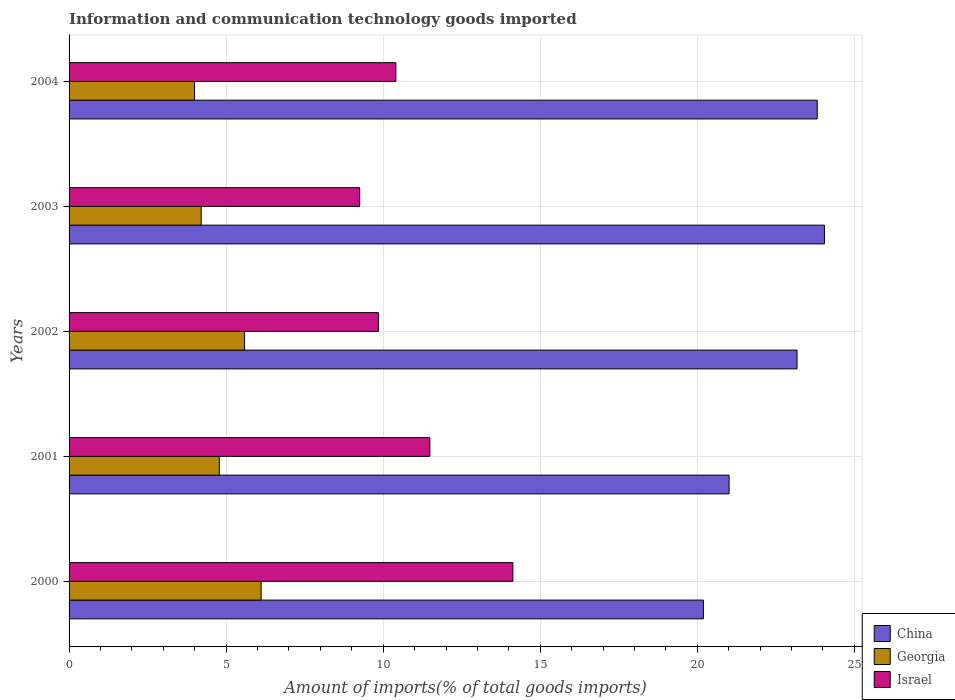How many groups of bars are there?
Keep it short and to the point. 5. Are the number of bars per tick equal to the number of legend labels?
Offer a very short reply. Yes. Are the number of bars on each tick of the Y-axis equal?
Provide a short and direct response. Yes. How many bars are there on the 1st tick from the top?
Provide a short and direct response. 3. How many bars are there on the 4th tick from the bottom?
Make the answer very short. 3. What is the amount of goods imported in Georgia in 2002?
Make the answer very short. 5.59. Across all years, what is the maximum amount of goods imported in China?
Ensure brevity in your answer.  24.05. Across all years, what is the minimum amount of goods imported in Israel?
Offer a terse response. 9.25. In which year was the amount of goods imported in Georgia maximum?
Give a very brief answer. 2000. In which year was the amount of goods imported in Georgia minimum?
Your response must be concise. 2004. What is the total amount of goods imported in Georgia in the graph?
Give a very brief answer. 24.68. What is the difference between the amount of goods imported in Israel in 2002 and that in 2004?
Give a very brief answer. -0.56. What is the difference between the amount of goods imported in Georgia in 2004 and the amount of goods imported in China in 2002?
Your response must be concise. -19.18. What is the average amount of goods imported in Georgia per year?
Your response must be concise. 4.94. In the year 2002, what is the difference between the amount of goods imported in Georgia and amount of goods imported in Israel?
Give a very brief answer. -4.26. What is the ratio of the amount of goods imported in Georgia in 2000 to that in 2004?
Ensure brevity in your answer.  1.53. Is the amount of goods imported in Israel in 2003 less than that in 2004?
Provide a short and direct response. Yes. What is the difference between the highest and the second highest amount of goods imported in Georgia?
Ensure brevity in your answer.  0.53. What is the difference between the highest and the lowest amount of goods imported in Georgia?
Your answer should be compact. 2.12. What does the 2nd bar from the top in 2004 represents?
Offer a very short reply. Georgia. What does the 1st bar from the bottom in 2003 represents?
Your answer should be very brief. China. Are all the bars in the graph horizontal?
Your answer should be very brief. Yes. What is the difference between two consecutive major ticks on the X-axis?
Give a very brief answer. 5. Are the values on the major ticks of X-axis written in scientific E-notation?
Provide a short and direct response. No. Does the graph contain any zero values?
Your answer should be compact. No. How are the legend labels stacked?
Offer a terse response. Vertical. What is the title of the graph?
Make the answer very short. Information and communication technology goods imported. Does "Iran" appear as one of the legend labels in the graph?
Provide a succinct answer. No. What is the label or title of the X-axis?
Provide a succinct answer. Amount of imports(% of total goods imports). What is the label or title of the Y-axis?
Your answer should be very brief. Years. What is the Amount of imports(% of total goods imports) in China in 2000?
Offer a terse response. 20.19. What is the Amount of imports(% of total goods imports) in Georgia in 2000?
Offer a very short reply. 6.11. What is the Amount of imports(% of total goods imports) of Israel in 2000?
Offer a very short reply. 14.13. What is the Amount of imports(% of total goods imports) of China in 2001?
Your answer should be compact. 21.01. What is the Amount of imports(% of total goods imports) of Georgia in 2001?
Ensure brevity in your answer.  4.78. What is the Amount of imports(% of total goods imports) in Israel in 2001?
Ensure brevity in your answer.  11.48. What is the Amount of imports(% of total goods imports) in China in 2002?
Your answer should be very brief. 23.17. What is the Amount of imports(% of total goods imports) in Georgia in 2002?
Your answer should be very brief. 5.59. What is the Amount of imports(% of total goods imports) of Israel in 2002?
Give a very brief answer. 9.85. What is the Amount of imports(% of total goods imports) in China in 2003?
Keep it short and to the point. 24.05. What is the Amount of imports(% of total goods imports) in Georgia in 2003?
Provide a short and direct response. 4.21. What is the Amount of imports(% of total goods imports) of Israel in 2003?
Offer a terse response. 9.25. What is the Amount of imports(% of total goods imports) in China in 2004?
Ensure brevity in your answer.  23.82. What is the Amount of imports(% of total goods imports) of Georgia in 2004?
Ensure brevity in your answer.  3.99. What is the Amount of imports(% of total goods imports) of Israel in 2004?
Your answer should be compact. 10.4. Across all years, what is the maximum Amount of imports(% of total goods imports) in China?
Your answer should be compact. 24.05. Across all years, what is the maximum Amount of imports(% of total goods imports) of Georgia?
Provide a short and direct response. 6.11. Across all years, what is the maximum Amount of imports(% of total goods imports) in Israel?
Make the answer very short. 14.13. Across all years, what is the minimum Amount of imports(% of total goods imports) in China?
Your answer should be very brief. 20.19. Across all years, what is the minimum Amount of imports(% of total goods imports) of Georgia?
Keep it short and to the point. 3.99. Across all years, what is the minimum Amount of imports(% of total goods imports) of Israel?
Your response must be concise. 9.25. What is the total Amount of imports(% of total goods imports) in China in the graph?
Your answer should be very brief. 112.24. What is the total Amount of imports(% of total goods imports) in Georgia in the graph?
Offer a terse response. 24.68. What is the total Amount of imports(% of total goods imports) of Israel in the graph?
Make the answer very short. 55.11. What is the difference between the Amount of imports(% of total goods imports) of China in 2000 and that in 2001?
Provide a short and direct response. -0.82. What is the difference between the Amount of imports(% of total goods imports) of Georgia in 2000 and that in 2001?
Offer a very short reply. 1.33. What is the difference between the Amount of imports(% of total goods imports) in Israel in 2000 and that in 2001?
Your answer should be compact. 2.64. What is the difference between the Amount of imports(% of total goods imports) of China in 2000 and that in 2002?
Provide a succinct answer. -2.98. What is the difference between the Amount of imports(% of total goods imports) in Georgia in 2000 and that in 2002?
Your response must be concise. 0.53. What is the difference between the Amount of imports(% of total goods imports) in Israel in 2000 and that in 2002?
Offer a terse response. 4.28. What is the difference between the Amount of imports(% of total goods imports) in China in 2000 and that in 2003?
Provide a short and direct response. -3.85. What is the difference between the Amount of imports(% of total goods imports) of Georgia in 2000 and that in 2003?
Offer a terse response. 1.91. What is the difference between the Amount of imports(% of total goods imports) in Israel in 2000 and that in 2003?
Make the answer very short. 4.88. What is the difference between the Amount of imports(% of total goods imports) of China in 2000 and that in 2004?
Ensure brevity in your answer.  -3.62. What is the difference between the Amount of imports(% of total goods imports) in Georgia in 2000 and that in 2004?
Your answer should be very brief. 2.12. What is the difference between the Amount of imports(% of total goods imports) of Israel in 2000 and that in 2004?
Keep it short and to the point. 3.72. What is the difference between the Amount of imports(% of total goods imports) of China in 2001 and that in 2002?
Provide a succinct answer. -2.16. What is the difference between the Amount of imports(% of total goods imports) in Georgia in 2001 and that in 2002?
Provide a succinct answer. -0.8. What is the difference between the Amount of imports(% of total goods imports) of Israel in 2001 and that in 2002?
Offer a very short reply. 1.64. What is the difference between the Amount of imports(% of total goods imports) in China in 2001 and that in 2003?
Your answer should be compact. -3.04. What is the difference between the Amount of imports(% of total goods imports) of Georgia in 2001 and that in 2003?
Keep it short and to the point. 0.57. What is the difference between the Amount of imports(% of total goods imports) in Israel in 2001 and that in 2003?
Your response must be concise. 2.23. What is the difference between the Amount of imports(% of total goods imports) in China in 2001 and that in 2004?
Give a very brief answer. -2.81. What is the difference between the Amount of imports(% of total goods imports) of Georgia in 2001 and that in 2004?
Your response must be concise. 0.79. What is the difference between the Amount of imports(% of total goods imports) in Israel in 2001 and that in 2004?
Offer a terse response. 1.08. What is the difference between the Amount of imports(% of total goods imports) in China in 2002 and that in 2003?
Keep it short and to the point. -0.87. What is the difference between the Amount of imports(% of total goods imports) of Georgia in 2002 and that in 2003?
Keep it short and to the point. 1.38. What is the difference between the Amount of imports(% of total goods imports) of Israel in 2002 and that in 2003?
Offer a terse response. 0.6. What is the difference between the Amount of imports(% of total goods imports) of China in 2002 and that in 2004?
Offer a terse response. -0.64. What is the difference between the Amount of imports(% of total goods imports) of Georgia in 2002 and that in 2004?
Keep it short and to the point. 1.59. What is the difference between the Amount of imports(% of total goods imports) in Israel in 2002 and that in 2004?
Make the answer very short. -0.56. What is the difference between the Amount of imports(% of total goods imports) in China in 2003 and that in 2004?
Keep it short and to the point. 0.23. What is the difference between the Amount of imports(% of total goods imports) of Georgia in 2003 and that in 2004?
Your answer should be compact. 0.21. What is the difference between the Amount of imports(% of total goods imports) in Israel in 2003 and that in 2004?
Keep it short and to the point. -1.15. What is the difference between the Amount of imports(% of total goods imports) of China in 2000 and the Amount of imports(% of total goods imports) of Georgia in 2001?
Offer a very short reply. 15.41. What is the difference between the Amount of imports(% of total goods imports) in China in 2000 and the Amount of imports(% of total goods imports) in Israel in 2001?
Make the answer very short. 8.71. What is the difference between the Amount of imports(% of total goods imports) of Georgia in 2000 and the Amount of imports(% of total goods imports) of Israel in 2001?
Offer a very short reply. -5.37. What is the difference between the Amount of imports(% of total goods imports) in China in 2000 and the Amount of imports(% of total goods imports) in Georgia in 2002?
Make the answer very short. 14.61. What is the difference between the Amount of imports(% of total goods imports) in China in 2000 and the Amount of imports(% of total goods imports) in Israel in 2002?
Keep it short and to the point. 10.35. What is the difference between the Amount of imports(% of total goods imports) in Georgia in 2000 and the Amount of imports(% of total goods imports) in Israel in 2002?
Keep it short and to the point. -3.73. What is the difference between the Amount of imports(% of total goods imports) of China in 2000 and the Amount of imports(% of total goods imports) of Georgia in 2003?
Your answer should be very brief. 15.99. What is the difference between the Amount of imports(% of total goods imports) of China in 2000 and the Amount of imports(% of total goods imports) of Israel in 2003?
Your response must be concise. 10.94. What is the difference between the Amount of imports(% of total goods imports) in Georgia in 2000 and the Amount of imports(% of total goods imports) in Israel in 2003?
Keep it short and to the point. -3.14. What is the difference between the Amount of imports(% of total goods imports) of China in 2000 and the Amount of imports(% of total goods imports) of Georgia in 2004?
Offer a very short reply. 16.2. What is the difference between the Amount of imports(% of total goods imports) of China in 2000 and the Amount of imports(% of total goods imports) of Israel in 2004?
Provide a short and direct response. 9.79. What is the difference between the Amount of imports(% of total goods imports) in Georgia in 2000 and the Amount of imports(% of total goods imports) in Israel in 2004?
Give a very brief answer. -4.29. What is the difference between the Amount of imports(% of total goods imports) in China in 2001 and the Amount of imports(% of total goods imports) in Georgia in 2002?
Your answer should be compact. 15.42. What is the difference between the Amount of imports(% of total goods imports) of China in 2001 and the Amount of imports(% of total goods imports) of Israel in 2002?
Provide a succinct answer. 11.16. What is the difference between the Amount of imports(% of total goods imports) in Georgia in 2001 and the Amount of imports(% of total goods imports) in Israel in 2002?
Your answer should be compact. -5.06. What is the difference between the Amount of imports(% of total goods imports) of China in 2001 and the Amount of imports(% of total goods imports) of Georgia in 2003?
Keep it short and to the point. 16.8. What is the difference between the Amount of imports(% of total goods imports) in China in 2001 and the Amount of imports(% of total goods imports) in Israel in 2003?
Your response must be concise. 11.76. What is the difference between the Amount of imports(% of total goods imports) of Georgia in 2001 and the Amount of imports(% of total goods imports) of Israel in 2003?
Make the answer very short. -4.47. What is the difference between the Amount of imports(% of total goods imports) of China in 2001 and the Amount of imports(% of total goods imports) of Georgia in 2004?
Your response must be concise. 17.02. What is the difference between the Amount of imports(% of total goods imports) of China in 2001 and the Amount of imports(% of total goods imports) of Israel in 2004?
Offer a very short reply. 10.61. What is the difference between the Amount of imports(% of total goods imports) in Georgia in 2001 and the Amount of imports(% of total goods imports) in Israel in 2004?
Offer a very short reply. -5.62. What is the difference between the Amount of imports(% of total goods imports) in China in 2002 and the Amount of imports(% of total goods imports) in Georgia in 2003?
Offer a terse response. 18.97. What is the difference between the Amount of imports(% of total goods imports) in China in 2002 and the Amount of imports(% of total goods imports) in Israel in 2003?
Your answer should be very brief. 13.92. What is the difference between the Amount of imports(% of total goods imports) of Georgia in 2002 and the Amount of imports(% of total goods imports) of Israel in 2003?
Offer a very short reply. -3.66. What is the difference between the Amount of imports(% of total goods imports) of China in 2002 and the Amount of imports(% of total goods imports) of Georgia in 2004?
Ensure brevity in your answer.  19.18. What is the difference between the Amount of imports(% of total goods imports) in China in 2002 and the Amount of imports(% of total goods imports) in Israel in 2004?
Your answer should be compact. 12.77. What is the difference between the Amount of imports(% of total goods imports) of Georgia in 2002 and the Amount of imports(% of total goods imports) of Israel in 2004?
Offer a terse response. -4.82. What is the difference between the Amount of imports(% of total goods imports) in China in 2003 and the Amount of imports(% of total goods imports) in Georgia in 2004?
Keep it short and to the point. 20.05. What is the difference between the Amount of imports(% of total goods imports) of China in 2003 and the Amount of imports(% of total goods imports) of Israel in 2004?
Offer a terse response. 13.64. What is the difference between the Amount of imports(% of total goods imports) in Georgia in 2003 and the Amount of imports(% of total goods imports) in Israel in 2004?
Your answer should be compact. -6.2. What is the average Amount of imports(% of total goods imports) in China per year?
Ensure brevity in your answer.  22.45. What is the average Amount of imports(% of total goods imports) of Georgia per year?
Your response must be concise. 4.94. What is the average Amount of imports(% of total goods imports) of Israel per year?
Provide a short and direct response. 11.02. In the year 2000, what is the difference between the Amount of imports(% of total goods imports) of China and Amount of imports(% of total goods imports) of Georgia?
Your answer should be very brief. 14.08. In the year 2000, what is the difference between the Amount of imports(% of total goods imports) in China and Amount of imports(% of total goods imports) in Israel?
Ensure brevity in your answer.  6.07. In the year 2000, what is the difference between the Amount of imports(% of total goods imports) of Georgia and Amount of imports(% of total goods imports) of Israel?
Your answer should be compact. -8.01. In the year 2001, what is the difference between the Amount of imports(% of total goods imports) of China and Amount of imports(% of total goods imports) of Georgia?
Give a very brief answer. 16.23. In the year 2001, what is the difference between the Amount of imports(% of total goods imports) of China and Amount of imports(% of total goods imports) of Israel?
Keep it short and to the point. 9.53. In the year 2001, what is the difference between the Amount of imports(% of total goods imports) in Georgia and Amount of imports(% of total goods imports) in Israel?
Keep it short and to the point. -6.7. In the year 2002, what is the difference between the Amount of imports(% of total goods imports) of China and Amount of imports(% of total goods imports) of Georgia?
Keep it short and to the point. 17.59. In the year 2002, what is the difference between the Amount of imports(% of total goods imports) of China and Amount of imports(% of total goods imports) of Israel?
Offer a very short reply. 13.33. In the year 2002, what is the difference between the Amount of imports(% of total goods imports) of Georgia and Amount of imports(% of total goods imports) of Israel?
Offer a terse response. -4.26. In the year 2003, what is the difference between the Amount of imports(% of total goods imports) of China and Amount of imports(% of total goods imports) of Georgia?
Provide a succinct answer. 19.84. In the year 2003, what is the difference between the Amount of imports(% of total goods imports) in China and Amount of imports(% of total goods imports) in Israel?
Your answer should be very brief. 14.8. In the year 2003, what is the difference between the Amount of imports(% of total goods imports) of Georgia and Amount of imports(% of total goods imports) of Israel?
Provide a short and direct response. -5.04. In the year 2004, what is the difference between the Amount of imports(% of total goods imports) of China and Amount of imports(% of total goods imports) of Georgia?
Give a very brief answer. 19.82. In the year 2004, what is the difference between the Amount of imports(% of total goods imports) in China and Amount of imports(% of total goods imports) in Israel?
Make the answer very short. 13.41. In the year 2004, what is the difference between the Amount of imports(% of total goods imports) of Georgia and Amount of imports(% of total goods imports) of Israel?
Make the answer very short. -6.41. What is the ratio of the Amount of imports(% of total goods imports) of China in 2000 to that in 2001?
Your answer should be very brief. 0.96. What is the ratio of the Amount of imports(% of total goods imports) in Georgia in 2000 to that in 2001?
Your response must be concise. 1.28. What is the ratio of the Amount of imports(% of total goods imports) in Israel in 2000 to that in 2001?
Your answer should be compact. 1.23. What is the ratio of the Amount of imports(% of total goods imports) in China in 2000 to that in 2002?
Offer a very short reply. 0.87. What is the ratio of the Amount of imports(% of total goods imports) in Georgia in 2000 to that in 2002?
Your answer should be very brief. 1.09. What is the ratio of the Amount of imports(% of total goods imports) in Israel in 2000 to that in 2002?
Your response must be concise. 1.43. What is the ratio of the Amount of imports(% of total goods imports) of China in 2000 to that in 2003?
Your response must be concise. 0.84. What is the ratio of the Amount of imports(% of total goods imports) in Georgia in 2000 to that in 2003?
Keep it short and to the point. 1.45. What is the ratio of the Amount of imports(% of total goods imports) in Israel in 2000 to that in 2003?
Keep it short and to the point. 1.53. What is the ratio of the Amount of imports(% of total goods imports) of China in 2000 to that in 2004?
Your response must be concise. 0.85. What is the ratio of the Amount of imports(% of total goods imports) in Georgia in 2000 to that in 2004?
Your answer should be compact. 1.53. What is the ratio of the Amount of imports(% of total goods imports) in Israel in 2000 to that in 2004?
Keep it short and to the point. 1.36. What is the ratio of the Amount of imports(% of total goods imports) in China in 2001 to that in 2002?
Offer a very short reply. 0.91. What is the ratio of the Amount of imports(% of total goods imports) of Georgia in 2001 to that in 2002?
Make the answer very short. 0.86. What is the ratio of the Amount of imports(% of total goods imports) in Israel in 2001 to that in 2002?
Ensure brevity in your answer.  1.17. What is the ratio of the Amount of imports(% of total goods imports) in China in 2001 to that in 2003?
Your response must be concise. 0.87. What is the ratio of the Amount of imports(% of total goods imports) of Georgia in 2001 to that in 2003?
Your response must be concise. 1.14. What is the ratio of the Amount of imports(% of total goods imports) of Israel in 2001 to that in 2003?
Give a very brief answer. 1.24. What is the ratio of the Amount of imports(% of total goods imports) of China in 2001 to that in 2004?
Offer a terse response. 0.88. What is the ratio of the Amount of imports(% of total goods imports) in Georgia in 2001 to that in 2004?
Offer a very short reply. 1.2. What is the ratio of the Amount of imports(% of total goods imports) in Israel in 2001 to that in 2004?
Provide a succinct answer. 1.1. What is the ratio of the Amount of imports(% of total goods imports) of China in 2002 to that in 2003?
Make the answer very short. 0.96. What is the ratio of the Amount of imports(% of total goods imports) of Georgia in 2002 to that in 2003?
Your answer should be very brief. 1.33. What is the ratio of the Amount of imports(% of total goods imports) of Israel in 2002 to that in 2003?
Your answer should be very brief. 1.06. What is the ratio of the Amount of imports(% of total goods imports) of China in 2002 to that in 2004?
Provide a short and direct response. 0.97. What is the ratio of the Amount of imports(% of total goods imports) of Georgia in 2002 to that in 2004?
Offer a very short reply. 1.4. What is the ratio of the Amount of imports(% of total goods imports) in Israel in 2002 to that in 2004?
Provide a short and direct response. 0.95. What is the ratio of the Amount of imports(% of total goods imports) in China in 2003 to that in 2004?
Provide a succinct answer. 1.01. What is the ratio of the Amount of imports(% of total goods imports) in Georgia in 2003 to that in 2004?
Keep it short and to the point. 1.05. What is the ratio of the Amount of imports(% of total goods imports) in Israel in 2003 to that in 2004?
Your answer should be very brief. 0.89. What is the difference between the highest and the second highest Amount of imports(% of total goods imports) of China?
Your answer should be very brief. 0.23. What is the difference between the highest and the second highest Amount of imports(% of total goods imports) of Georgia?
Your answer should be compact. 0.53. What is the difference between the highest and the second highest Amount of imports(% of total goods imports) of Israel?
Provide a short and direct response. 2.64. What is the difference between the highest and the lowest Amount of imports(% of total goods imports) of China?
Provide a short and direct response. 3.85. What is the difference between the highest and the lowest Amount of imports(% of total goods imports) in Georgia?
Your response must be concise. 2.12. What is the difference between the highest and the lowest Amount of imports(% of total goods imports) of Israel?
Keep it short and to the point. 4.88. 